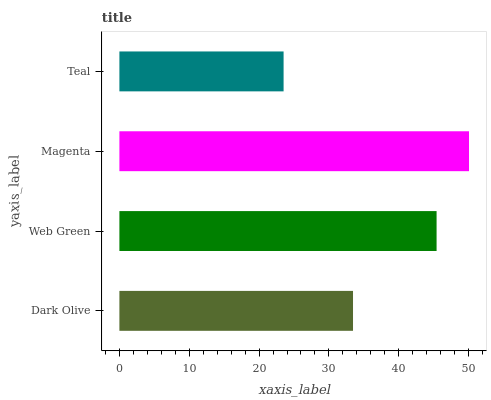Is Teal the minimum?
Answer yes or no. Yes. Is Magenta the maximum?
Answer yes or no. Yes. Is Web Green the minimum?
Answer yes or no. No. Is Web Green the maximum?
Answer yes or no. No. Is Web Green greater than Dark Olive?
Answer yes or no. Yes. Is Dark Olive less than Web Green?
Answer yes or no. Yes. Is Dark Olive greater than Web Green?
Answer yes or no. No. Is Web Green less than Dark Olive?
Answer yes or no. No. Is Web Green the high median?
Answer yes or no. Yes. Is Dark Olive the low median?
Answer yes or no. Yes. Is Dark Olive the high median?
Answer yes or no. No. Is Magenta the low median?
Answer yes or no. No. 